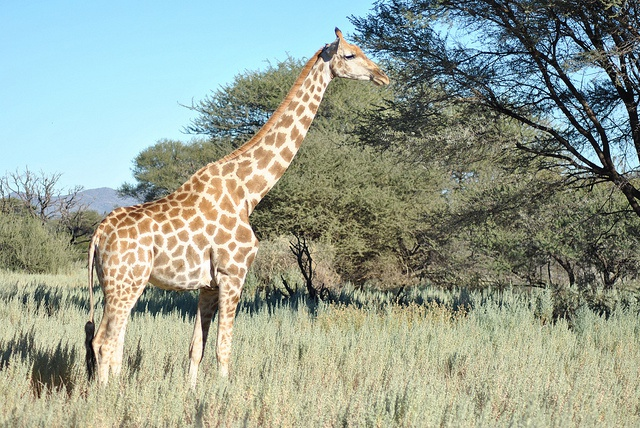Describe the objects in this image and their specific colors. I can see a giraffe in lightblue, beige, and tan tones in this image. 